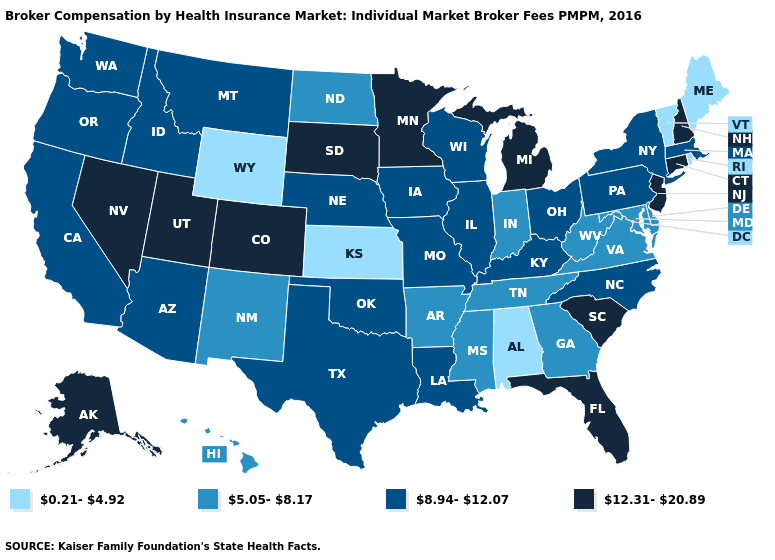What is the lowest value in states that border Mississippi?
Short answer required. 0.21-4.92. What is the lowest value in the South?
Concise answer only. 0.21-4.92. Does New York have the highest value in the USA?
Be succinct. No. Does Hawaii have a lower value than Alabama?
Be succinct. No. What is the value of Vermont?
Short answer required. 0.21-4.92. Name the states that have a value in the range 0.21-4.92?
Quick response, please. Alabama, Kansas, Maine, Rhode Island, Vermont, Wyoming. Does the first symbol in the legend represent the smallest category?
Answer briefly. Yes. Name the states that have a value in the range 5.05-8.17?
Give a very brief answer. Arkansas, Delaware, Georgia, Hawaii, Indiana, Maryland, Mississippi, New Mexico, North Dakota, Tennessee, Virginia, West Virginia. What is the lowest value in the USA?
Keep it brief. 0.21-4.92. Does Wisconsin have a lower value than New York?
Be succinct. No. What is the highest value in the West ?
Write a very short answer. 12.31-20.89. Does Maine have the highest value in the USA?
Quick response, please. No. Does Pennsylvania have the same value as Minnesota?
Quick response, please. No. What is the lowest value in the USA?
Answer briefly. 0.21-4.92. Is the legend a continuous bar?
Concise answer only. No. 